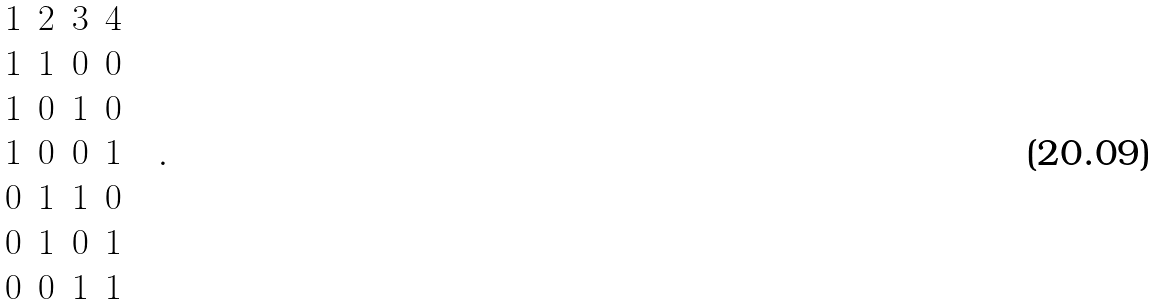<formula> <loc_0><loc_0><loc_500><loc_500>\begin{matrix} 1 & 2 & 3 & 4 \\ 1 & 1 & 0 & 0 \\ 1 & 0 & 1 & 0 \\ 1 & 0 & 0 & 1 \\ 0 & 1 & 1 & 0 \\ 0 & 1 & 0 & 1 \\ 0 & 0 & 1 & 1 \end{matrix} \quad .</formula> 